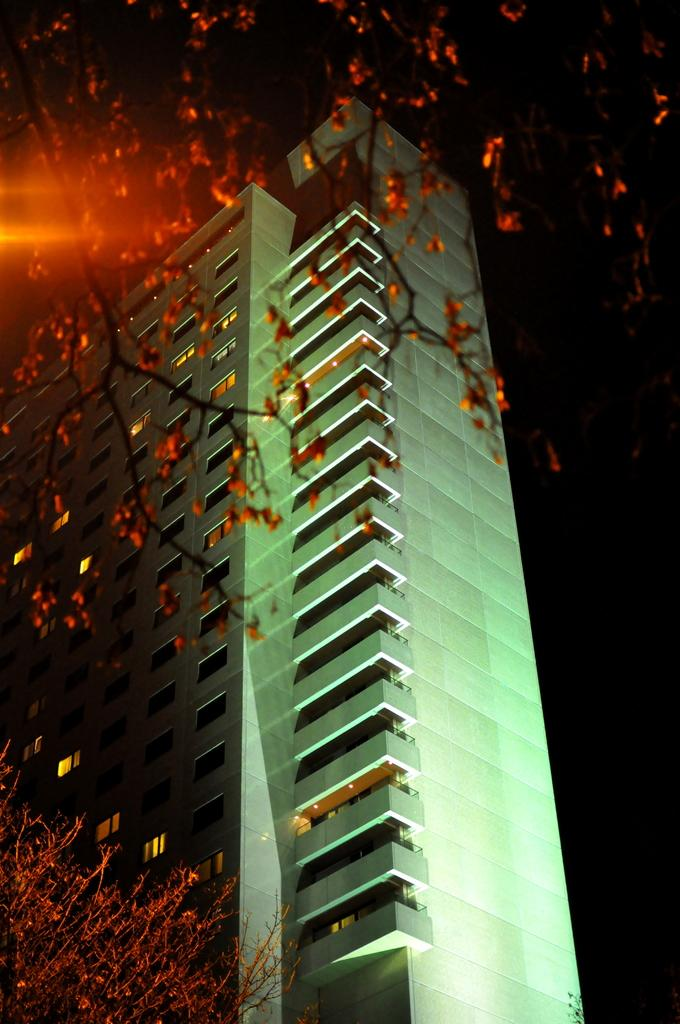What is the main subject in the center of the image? There is a building in the center of the image. What can be seen in the foreground of the image? Trees are present in the foreground of the image. What is visible in the background of the image? The sky is visible in the background of the image. How many seeds can be seen on the tramp in the image? There is no tramp or seeds present in the image. 